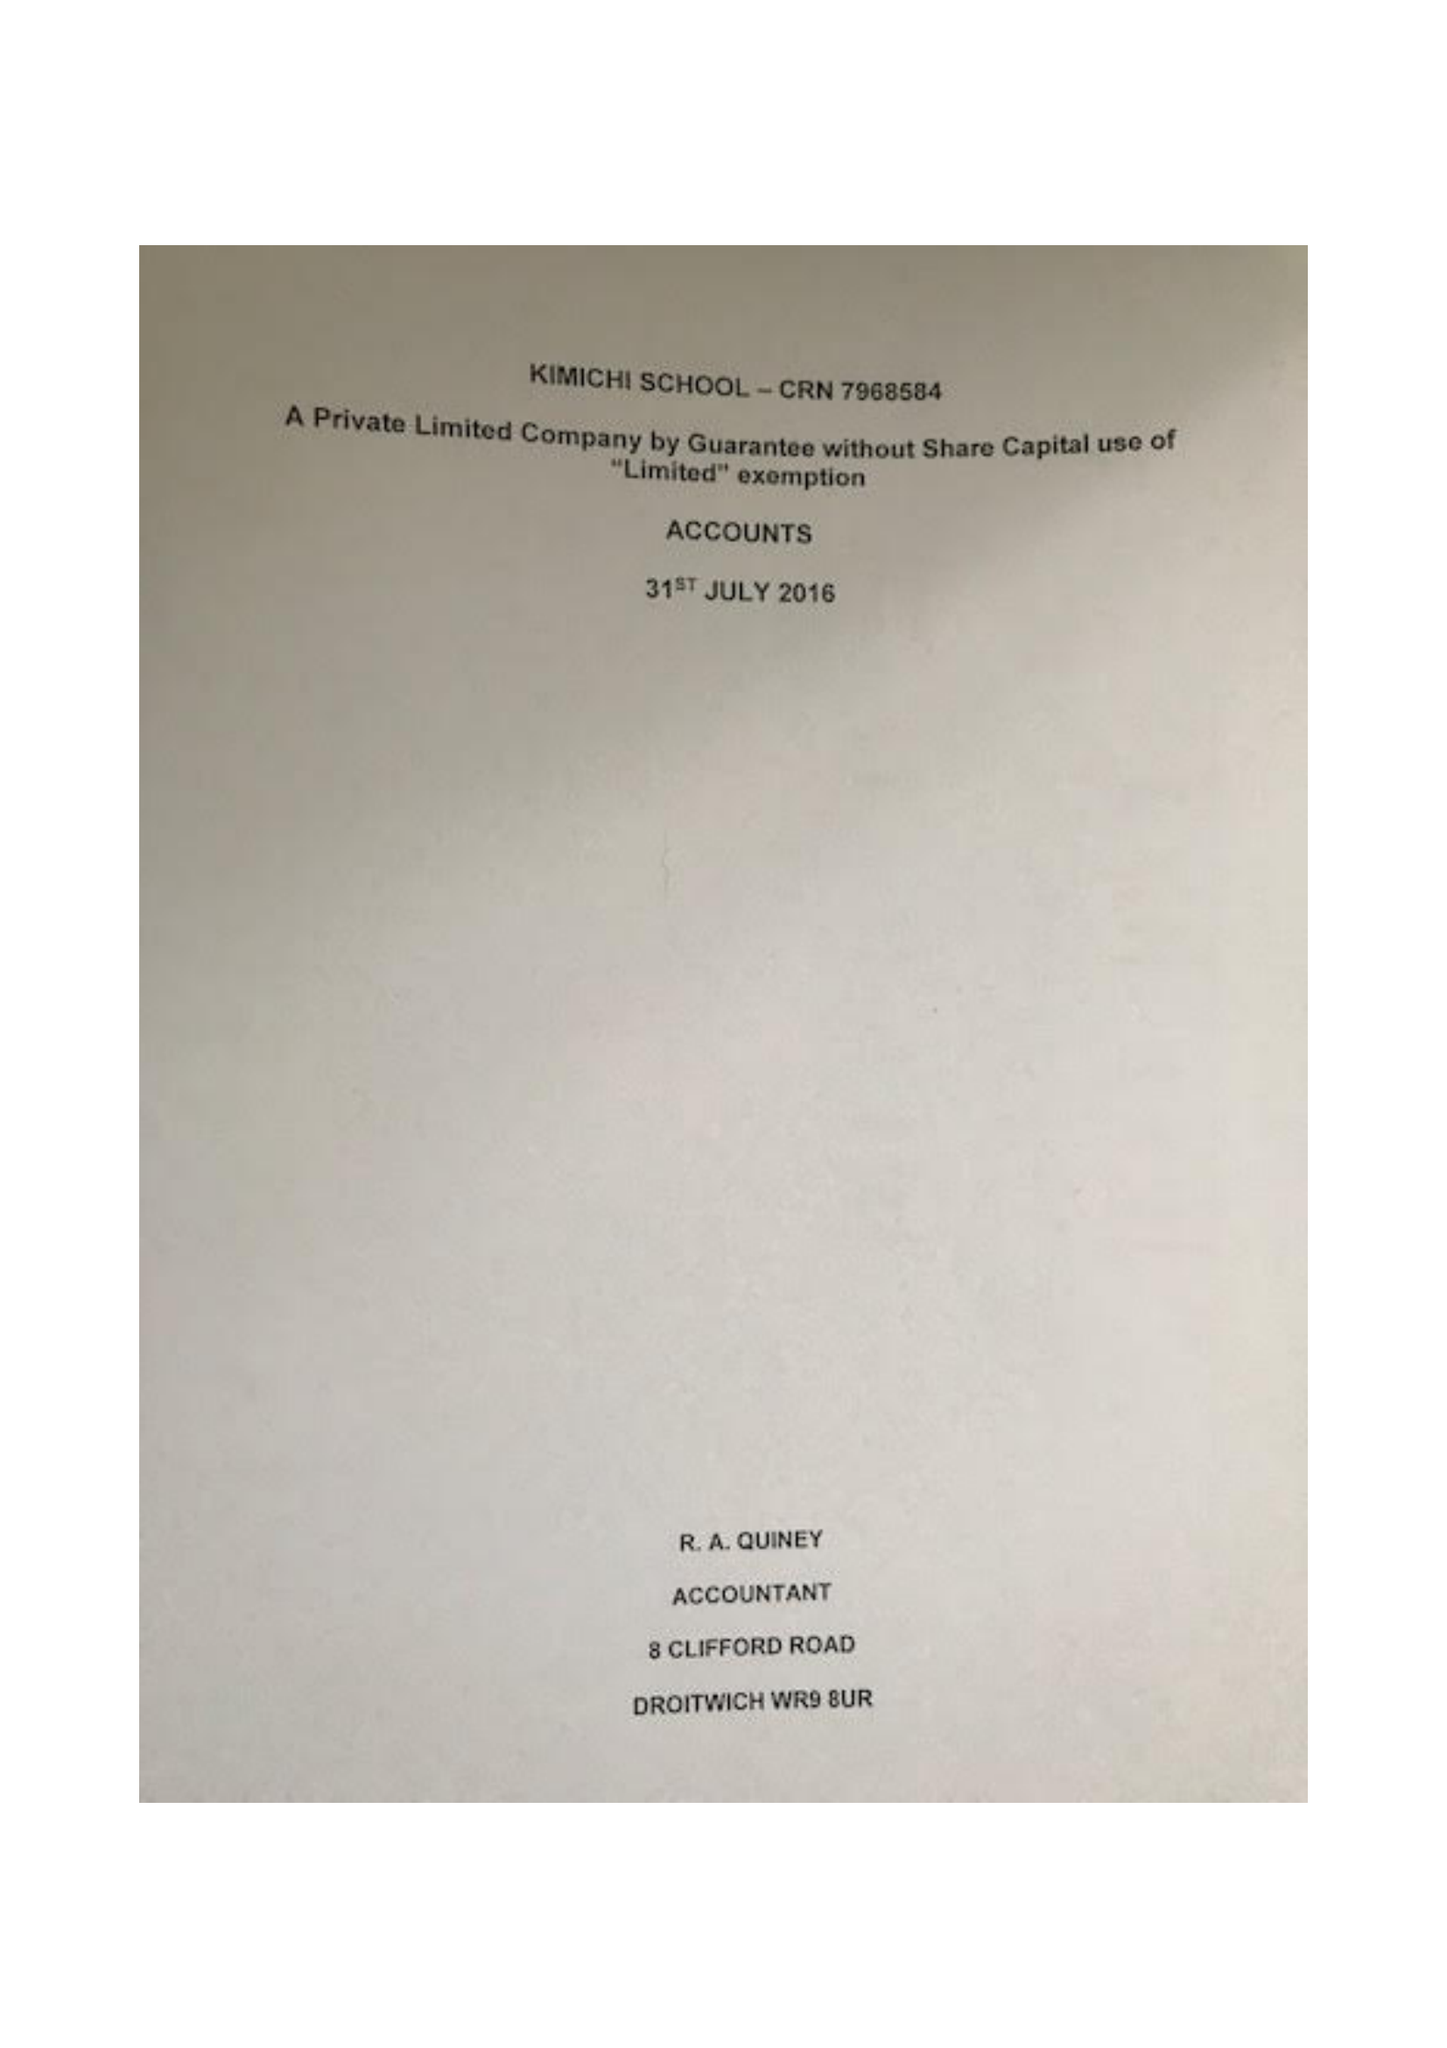What is the value for the report_date?
Answer the question using a single word or phrase. 2016-07-31 